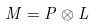<formula> <loc_0><loc_0><loc_500><loc_500>M = P \otimes L</formula> 